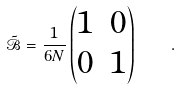Convert formula to latex. <formula><loc_0><loc_0><loc_500><loc_500>\tilde { \mathcal { B } } = \frac { 1 } { 6 N } \begin{pmatrix} 1 & 0 \\ 0 & 1 \end{pmatrix} \quad .</formula> 